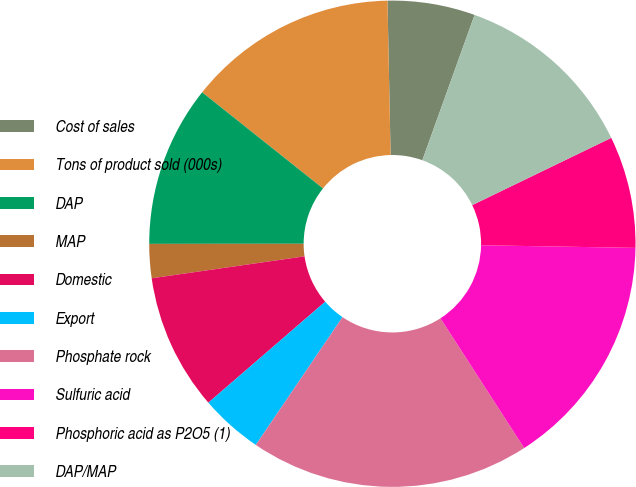Convert chart to OTSL. <chart><loc_0><loc_0><loc_500><loc_500><pie_chart><fcel>Cost of sales<fcel>Tons of product sold (000s)<fcel>DAP<fcel>MAP<fcel>Domestic<fcel>Export<fcel>Phosphate rock<fcel>Sulfuric acid<fcel>Phosphoric acid as P2O5 (1)<fcel>DAP/MAP<nl><fcel>5.81%<fcel>13.98%<fcel>10.71%<fcel>2.26%<fcel>9.07%<fcel>4.17%<fcel>18.61%<fcel>15.61%<fcel>7.44%<fcel>12.34%<nl></chart> 